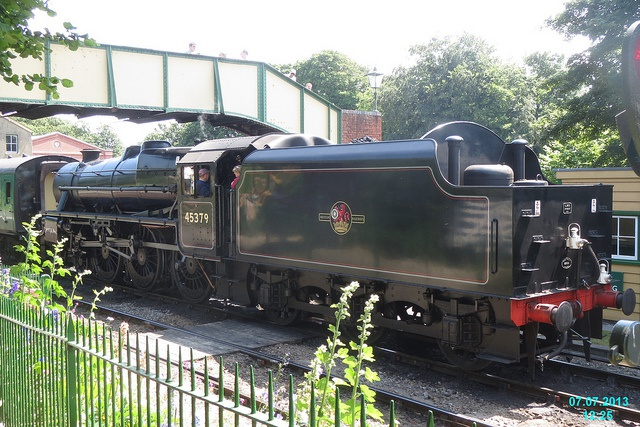Describe the objects in this image and their specific colors. I can see train in darkgreen, black, gray, and purple tones, traffic light in darkgreen and gray tones, people in darkgreen, black, and gray tones, people in darkgreen, black, gray, and brown tones, and people in darkgreen, gray, brown, and black tones in this image. 